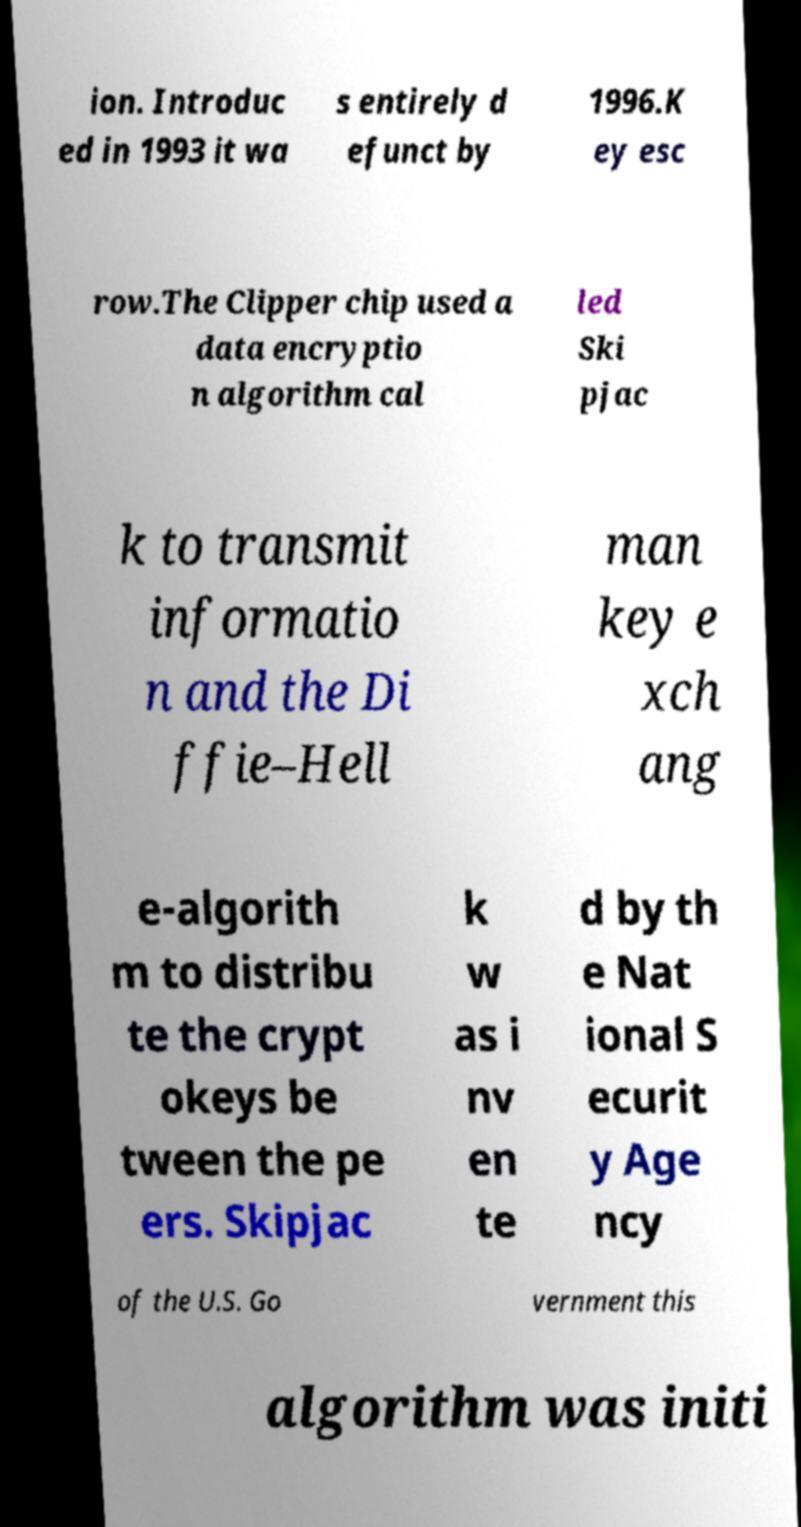There's text embedded in this image that I need extracted. Can you transcribe it verbatim? ion. Introduc ed in 1993 it wa s entirely d efunct by 1996.K ey esc row.The Clipper chip used a data encryptio n algorithm cal led Ski pjac k to transmit informatio n and the Di ffie–Hell man key e xch ang e-algorith m to distribu te the crypt okeys be tween the pe ers. Skipjac k w as i nv en te d by th e Nat ional S ecurit y Age ncy of the U.S. Go vernment this algorithm was initi 